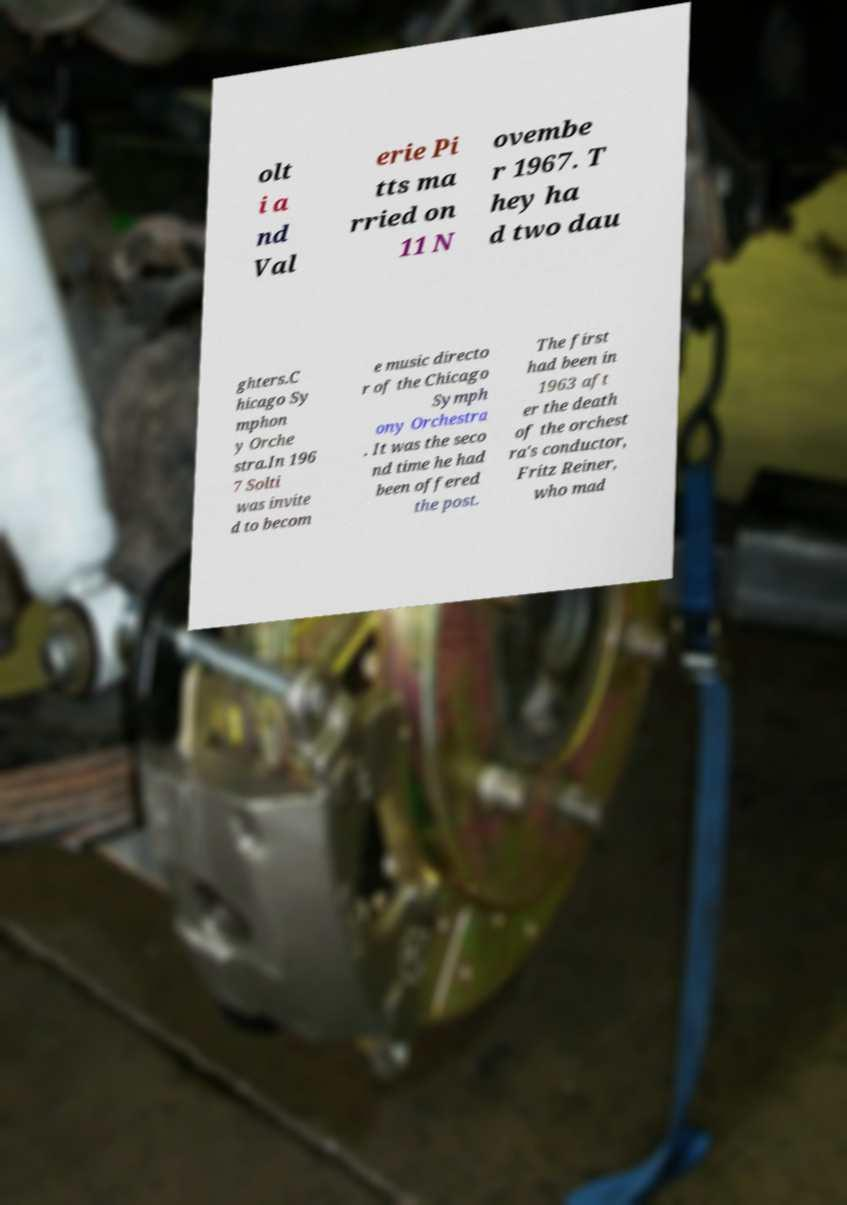Could you assist in decoding the text presented in this image and type it out clearly? olt i a nd Val erie Pi tts ma rried on 11 N ovembe r 1967. T hey ha d two dau ghters.C hicago Sy mphon y Orche stra.In 196 7 Solti was invite d to becom e music directo r of the Chicago Symph ony Orchestra . It was the seco nd time he had been offered the post. The first had been in 1963 aft er the death of the orchest ra's conductor, Fritz Reiner, who mad 